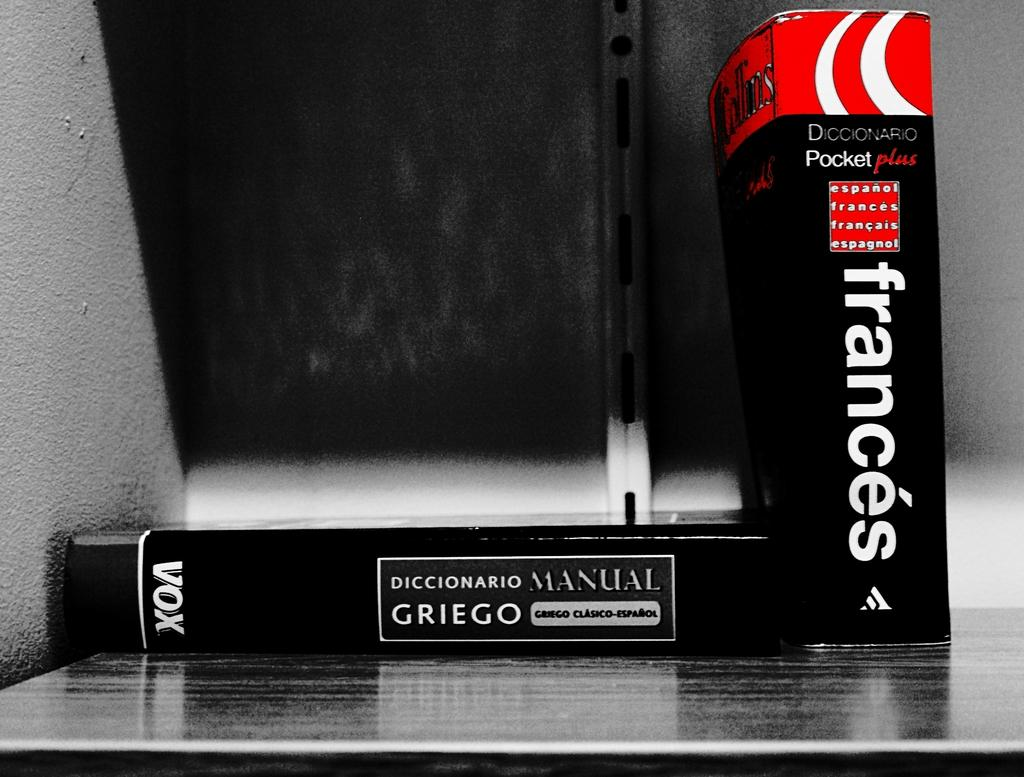<image>
Give a short and clear explanation of the subsequent image. The book and dictionary manual are both written in French. 